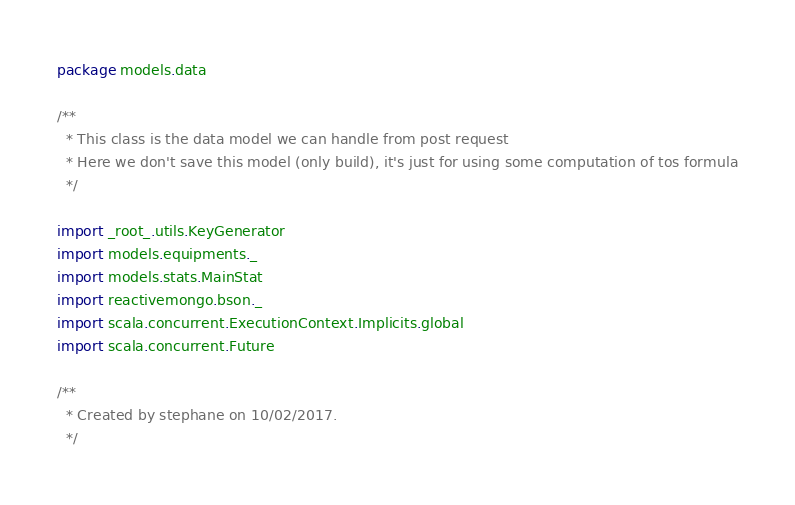<code> <loc_0><loc_0><loc_500><loc_500><_Scala_>package models.data

/**
  * This class is the data model we can handle from post request
  * Here we don't save this model (only build), it's just for using some computation of tos formula
  */

import _root_.utils.KeyGenerator
import models.equipments._
import models.stats.MainStat
import reactivemongo.bson._
import scala.concurrent.ExecutionContext.Implicits.global
import scala.concurrent.Future

/**
  * Created by stephane on 10/02/2017.
  */


</code> 